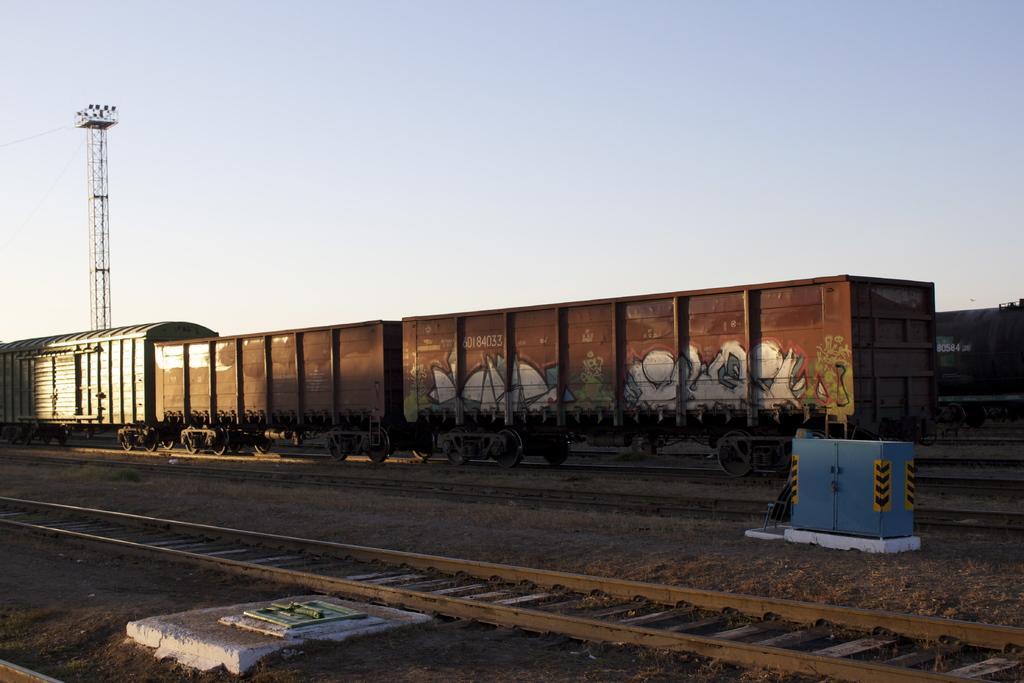Please provide a concise description of this image. This picture is taken inside the railway station. In this image, on the right side, we can see an electrical equipment. On the left side, we can see a floor. In the middle of the image, we can see a train which is placed on the railway track. In the background, we can see some trees, electric pole. At the top, we can see a sky, at the bottom, we can see a railway track with some stones. 